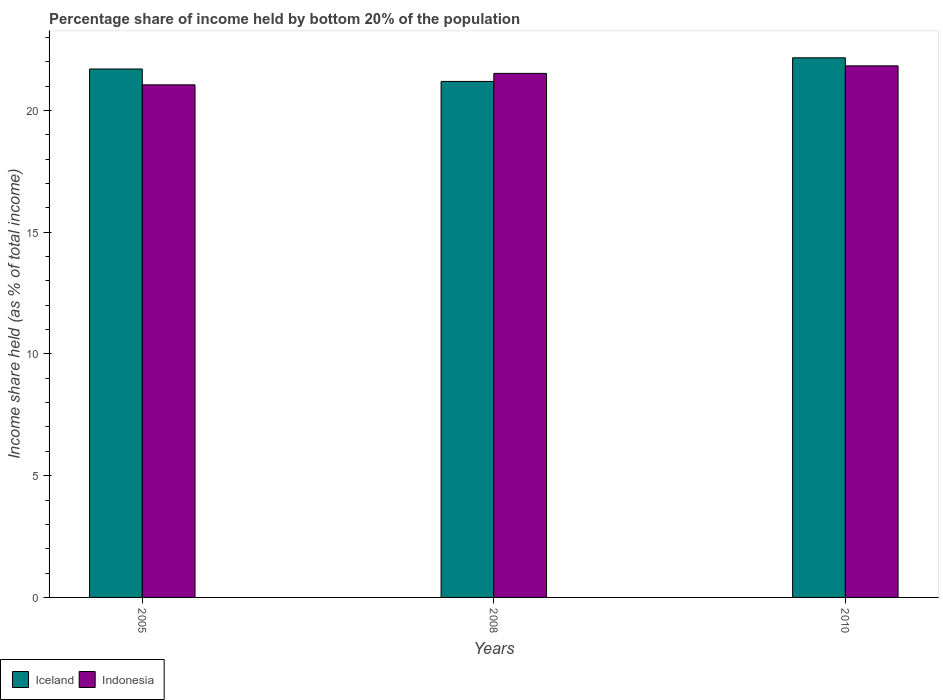How many different coloured bars are there?
Provide a succinct answer. 2. How many groups of bars are there?
Give a very brief answer. 3. How many bars are there on the 3rd tick from the left?
Offer a terse response. 2. How many bars are there on the 1st tick from the right?
Keep it short and to the point. 2. What is the share of income held by bottom 20% of the population in Indonesia in 2010?
Make the answer very short. 21.83. Across all years, what is the maximum share of income held by bottom 20% of the population in Iceland?
Make the answer very short. 22.16. Across all years, what is the minimum share of income held by bottom 20% of the population in Indonesia?
Offer a very short reply. 21.05. In which year was the share of income held by bottom 20% of the population in Indonesia minimum?
Provide a succinct answer. 2005. What is the total share of income held by bottom 20% of the population in Indonesia in the graph?
Your response must be concise. 64.4. What is the difference between the share of income held by bottom 20% of the population in Iceland in 2005 and that in 2008?
Give a very brief answer. 0.51. What is the difference between the share of income held by bottom 20% of the population in Indonesia in 2008 and the share of income held by bottom 20% of the population in Iceland in 2005?
Your response must be concise. -0.18. What is the average share of income held by bottom 20% of the population in Iceland per year?
Make the answer very short. 21.68. In the year 2010, what is the difference between the share of income held by bottom 20% of the population in Indonesia and share of income held by bottom 20% of the population in Iceland?
Provide a succinct answer. -0.33. What is the ratio of the share of income held by bottom 20% of the population in Iceland in 2005 to that in 2008?
Provide a succinct answer. 1.02. What is the difference between the highest and the second highest share of income held by bottom 20% of the population in Indonesia?
Provide a short and direct response. 0.31. What is the difference between the highest and the lowest share of income held by bottom 20% of the population in Indonesia?
Offer a very short reply. 0.78. Is the sum of the share of income held by bottom 20% of the population in Indonesia in 2005 and 2008 greater than the maximum share of income held by bottom 20% of the population in Iceland across all years?
Make the answer very short. Yes. What does the 2nd bar from the left in 2008 represents?
Ensure brevity in your answer.  Indonesia. What does the 2nd bar from the right in 2008 represents?
Your response must be concise. Iceland. Are all the bars in the graph horizontal?
Your answer should be very brief. No. Does the graph contain grids?
Your answer should be very brief. No. How many legend labels are there?
Your answer should be compact. 2. What is the title of the graph?
Keep it short and to the point. Percentage share of income held by bottom 20% of the population. What is the label or title of the Y-axis?
Ensure brevity in your answer.  Income share held (as % of total income). What is the Income share held (as % of total income) in Iceland in 2005?
Your response must be concise. 21.7. What is the Income share held (as % of total income) of Indonesia in 2005?
Offer a very short reply. 21.05. What is the Income share held (as % of total income) of Iceland in 2008?
Your response must be concise. 21.19. What is the Income share held (as % of total income) in Indonesia in 2008?
Offer a very short reply. 21.52. What is the Income share held (as % of total income) of Iceland in 2010?
Your answer should be very brief. 22.16. What is the Income share held (as % of total income) in Indonesia in 2010?
Give a very brief answer. 21.83. Across all years, what is the maximum Income share held (as % of total income) in Iceland?
Keep it short and to the point. 22.16. Across all years, what is the maximum Income share held (as % of total income) in Indonesia?
Ensure brevity in your answer.  21.83. Across all years, what is the minimum Income share held (as % of total income) of Iceland?
Offer a terse response. 21.19. Across all years, what is the minimum Income share held (as % of total income) of Indonesia?
Give a very brief answer. 21.05. What is the total Income share held (as % of total income) of Iceland in the graph?
Provide a short and direct response. 65.05. What is the total Income share held (as % of total income) in Indonesia in the graph?
Your response must be concise. 64.4. What is the difference between the Income share held (as % of total income) in Iceland in 2005 and that in 2008?
Your answer should be very brief. 0.51. What is the difference between the Income share held (as % of total income) in Indonesia in 2005 and that in 2008?
Ensure brevity in your answer.  -0.47. What is the difference between the Income share held (as % of total income) in Iceland in 2005 and that in 2010?
Your answer should be compact. -0.46. What is the difference between the Income share held (as % of total income) of Indonesia in 2005 and that in 2010?
Your answer should be compact. -0.78. What is the difference between the Income share held (as % of total income) of Iceland in 2008 and that in 2010?
Your answer should be very brief. -0.97. What is the difference between the Income share held (as % of total income) of Indonesia in 2008 and that in 2010?
Offer a terse response. -0.31. What is the difference between the Income share held (as % of total income) of Iceland in 2005 and the Income share held (as % of total income) of Indonesia in 2008?
Keep it short and to the point. 0.18. What is the difference between the Income share held (as % of total income) of Iceland in 2005 and the Income share held (as % of total income) of Indonesia in 2010?
Make the answer very short. -0.13. What is the difference between the Income share held (as % of total income) in Iceland in 2008 and the Income share held (as % of total income) in Indonesia in 2010?
Offer a terse response. -0.64. What is the average Income share held (as % of total income) of Iceland per year?
Give a very brief answer. 21.68. What is the average Income share held (as % of total income) in Indonesia per year?
Offer a very short reply. 21.47. In the year 2005, what is the difference between the Income share held (as % of total income) in Iceland and Income share held (as % of total income) in Indonesia?
Provide a succinct answer. 0.65. In the year 2008, what is the difference between the Income share held (as % of total income) of Iceland and Income share held (as % of total income) of Indonesia?
Your answer should be compact. -0.33. In the year 2010, what is the difference between the Income share held (as % of total income) of Iceland and Income share held (as % of total income) of Indonesia?
Offer a terse response. 0.33. What is the ratio of the Income share held (as % of total income) in Iceland in 2005 to that in 2008?
Your response must be concise. 1.02. What is the ratio of the Income share held (as % of total income) in Indonesia in 2005 to that in 2008?
Keep it short and to the point. 0.98. What is the ratio of the Income share held (as % of total income) of Iceland in 2005 to that in 2010?
Provide a short and direct response. 0.98. What is the ratio of the Income share held (as % of total income) in Iceland in 2008 to that in 2010?
Offer a terse response. 0.96. What is the ratio of the Income share held (as % of total income) of Indonesia in 2008 to that in 2010?
Offer a very short reply. 0.99. What is the difference between the highest and the second highest Income share held (as % of total income) in Iceland?
Provide a short and direct response. 0.46. What is the difference between the highest and the second highest Income share held (as % of total income) of Indonesia?
Your response must be concise. 0.31. What is the difference between the highest and the lowest Income share held (as % of total income) in Iceland?
Offer a very short reply. 0.97. What is the difference between the highest and the lowest Income share held (as % of total income) of Indonesia?
Provide a succinct answer. 0.78. 